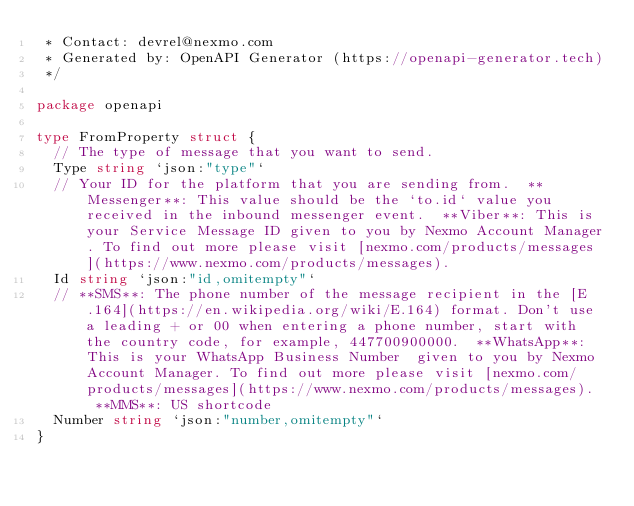<code> <loc_0><loc_0><loc_500><loc_500><_Go_> * Contact: devrel@nexmo.com
 * Generated by: OpenAPI Generator (https://openapi-generator.tech)
 */

package openapi

type FromProperty struct {
	// The type of message that you want to send.
	Type string `json:"type"`
	// Your ID for the platform that you are sending from.  **Messenger**: This value should be the `to.id` value you received in the inbound messenger event.  **Viber**: This is your Service Message ID given to you by Nexmo Account Manager. To find out more please visit [nexmo.com/products/messages](https://www.nexmo.com/products/messages). 
	Id string `json:"id,omitempty"`
	// **SMS**: The phone number of the message recipient in the [E.164](https://en.wikipedia.org/wiki/E.164) format. Don't use a leading + or 00 when entering a phone number, start with the country code, for example, 447700900000.  **WhatsApp**: This is your WhatsApp Business Number  given to you by Nexmo Account Manager. To find out more please visit [nexmo.com/products/messages](https://www.nexmo.com/products/messages).  **MMS**: US shortcode 
	Number string `json:"number,omitempty"`
}
</code> 